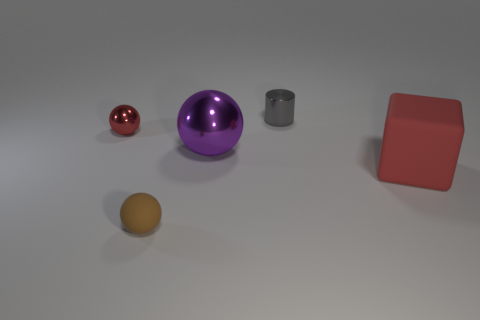There is a large thing that is the same color as the tiny shiny sphere; what material is it?
Make the answer very short. Rubber. Are there any blue shiny balls that have the same size as the red rubber object?
Offer a terse response. No. Is the material of the small cylinder the same as the sphere behind the big purple ball?
Keep it short and to the point. Yes. Is the number of red metallic things greater than the number of small metallic things?
Keep it short and to the point. No. What number of cubes are tiny green shiny things or matte things?
Keep it short and to the point. 1. What is the color of the cube?
Make the answer very short. Red. Does the rubber object in front of the red cube have the same size as the red object that is on the right side of the big purple object?
Keep it short and to the point. No. Are there fewer purple shiny objects than tiny spheres?
Give a very brief answer. Yes. There is a cylinder; what number of large red cubes are in front of it?
Provide a succinct answer. 1. What material is the big cube?
Provide a succinct answer. Rubber. 